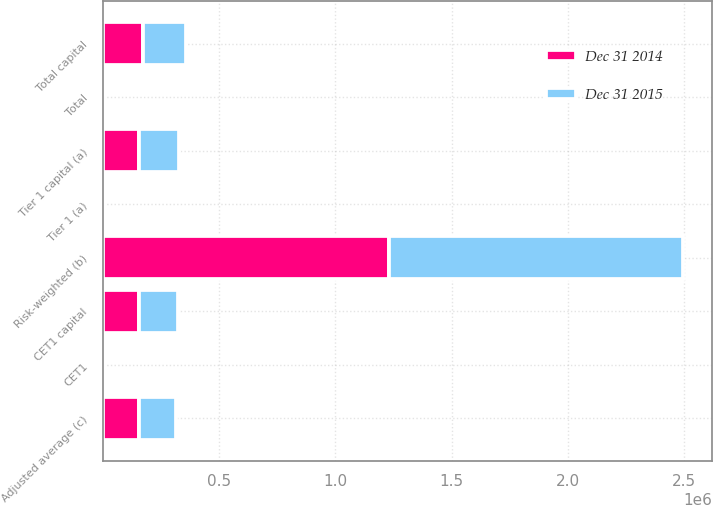<chart> <loc_0><loc_0><loc_500><loc_500><stacked_bar_chart><ecel><fcel>CET1 capital<fcel>Tier 1 capital (a)<fcel>Total capital<fcel>Risk-weighted (b)<fcel>Adjusted average (c)<fcel>CET1<fcel>Tier 1 (a)<fcel>Total<nl><fcel>Dec 31 2015<fcel>168857<fcel>169222<fcel>183262<fcel>1.26406e+06<fcel>156729<fcel>13.4<fcel>13.4<fcel>14.5<nl><fcel>Dec 31 2014<fcel>156567<fcel>156891<fcel>173322<fcel>1.23036e+06<fcel>156729<fcel>12.7<fcel>12.8<fcel>14.1<nl></chart> 